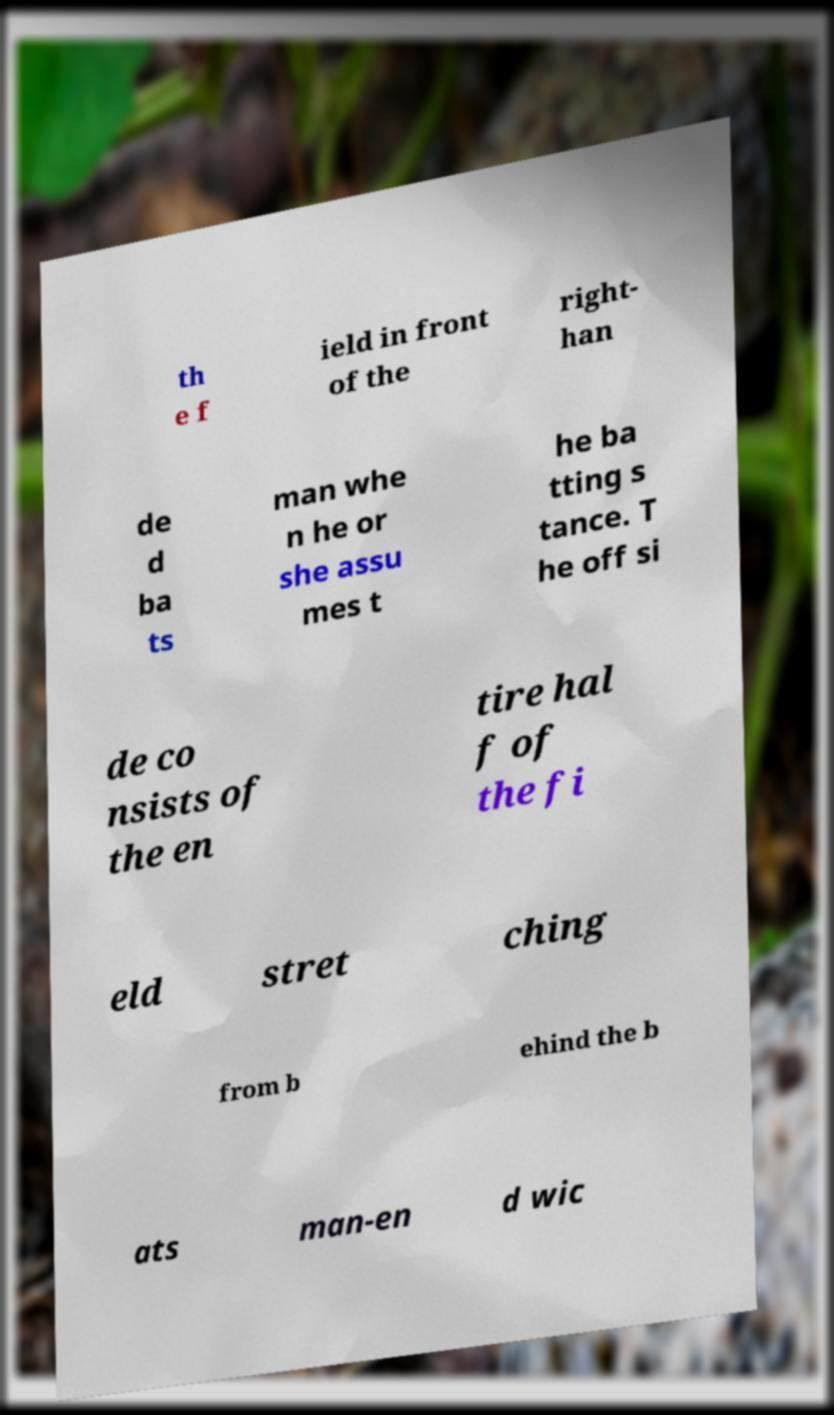Please identify and transcribe the text found in this image. th e f ield in front of the right- han de d ba ts man whe n he or she assu mes t he ba tting s tance. T he off si de co nsists of the en tire hal f of the fi eld stret ching from b ehind the b ats man-en d wic 